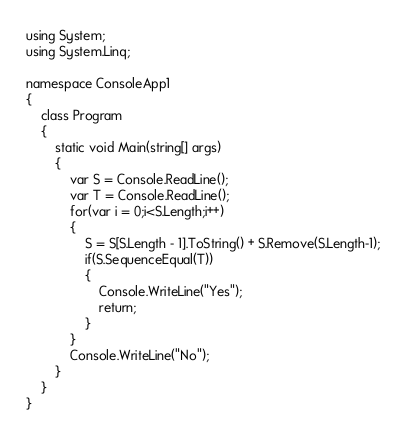Convert code to text. <code><loc_0><loc_0><loc_500><loc_500><_C#_>using System;
using System.Linq;

namespace ConsoleApp1
{
    class Program
    {
        static void Main(string[] args)
        {
            var S = Console.ReadLine();
            var T = Console.ReadLine();
            for(var i = 0;i<S.Length;i++)
            {
                S = S[S.Length - 1].ToString() + S.Remove(S.Length-1);
                if(S.SequenceEqual(T))
                {
                    Console.WriteLine("Yes");
                    return;
                }
            }
            Console.WriteLine("No");
        }
    }
}
</code> 